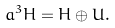<formula> <loc_0><loc_0><loc_500><loc_500>\L a ^ { 3 } H = H \oplus U .</formula> 